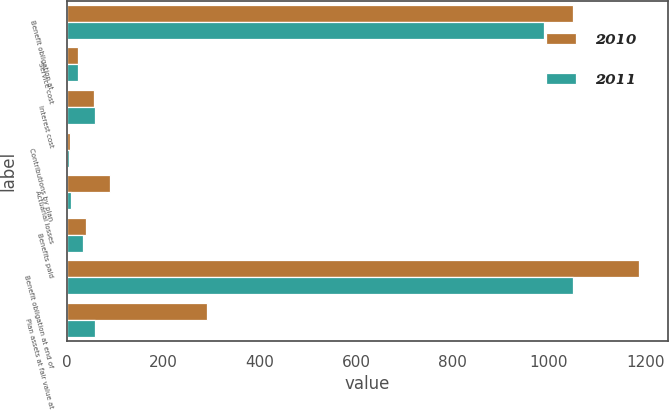Convert chart to OTSL. <chart><loc_0><loc_0><loc_500><loc_500><stacked_bar_chart><ecel><fcel>Benefit obligation at<fcel>Service cost<fcel>Interest cost<fcel>Contributions by plan<fcel>Actuarial losses<fcel>Benefits paid<fcel>Benefit obligation at end of<fcel>Plan assets at fair value at<nl><fcel>2010<fcel>1051<fcel>24<fcel>57<fcel>6<fcel>90<fcel>40<fcel>1188<fcel>290<nl><fcel>2011<fcel>991<fcel>23<fcel>58<fcel>4<fcel>8<fcel>33<fcel>1051<fcel>58<nl></chart> 